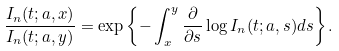<formula> <loc_0><loc_0><loc_500><loc_500>\frac { I _ { n } ( t ; { a } , x ) } { I _ { n } ( t ; { a } , y ) } = \exp \left \{ - \int _ { x } ^ { y } \frac { \partial } { \partial s } \log I _ { n } ( t ; { a } , s ) d s \right \} .</formula> 